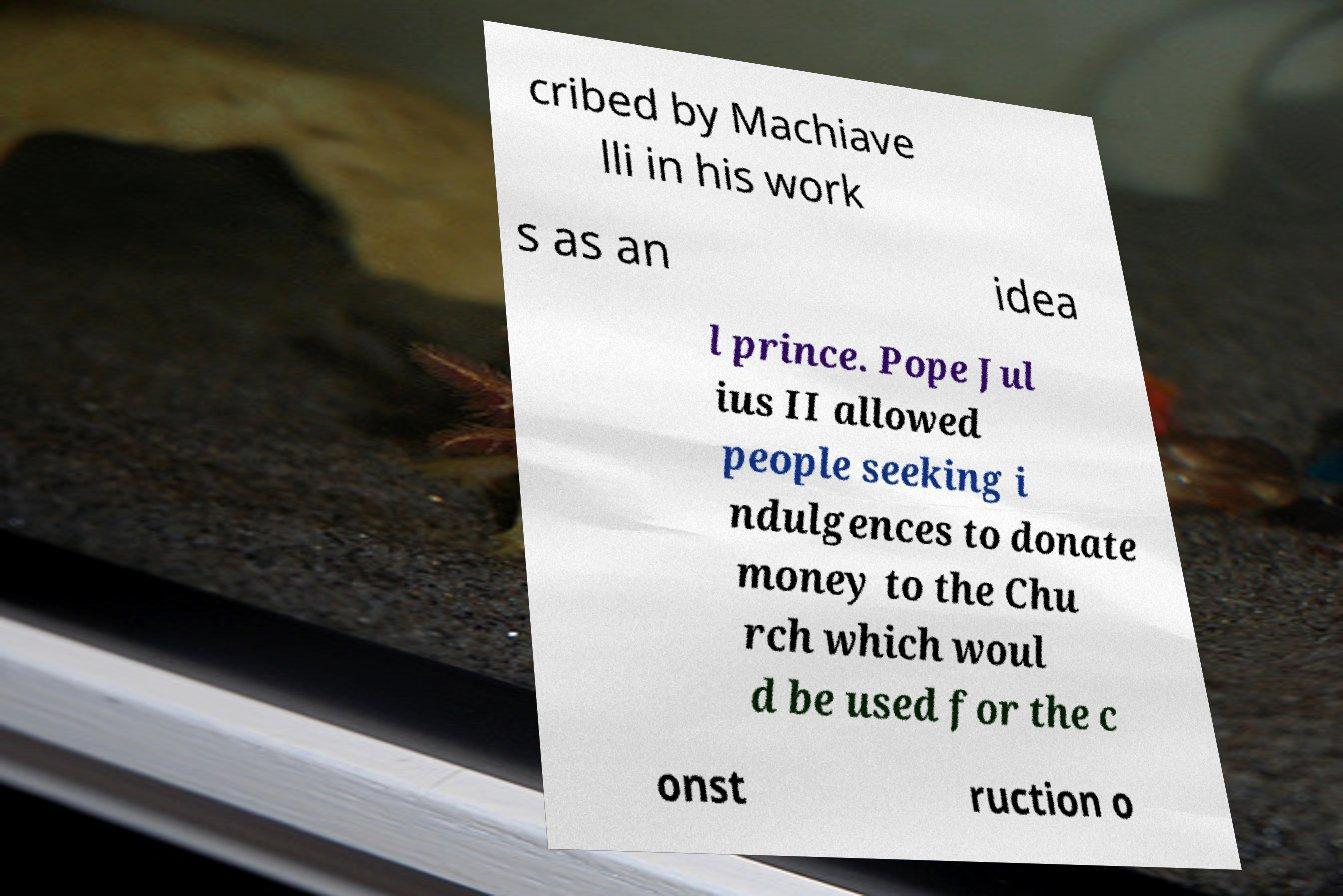Please read and relay the text visible in this image. What does it say? cribed by Machiave lli in his work s as an idea l prince. Pope Jul ius II allowed people seeking i ndulgences to donate money to the Chu rch which woul d be used for the c onst ruction o 